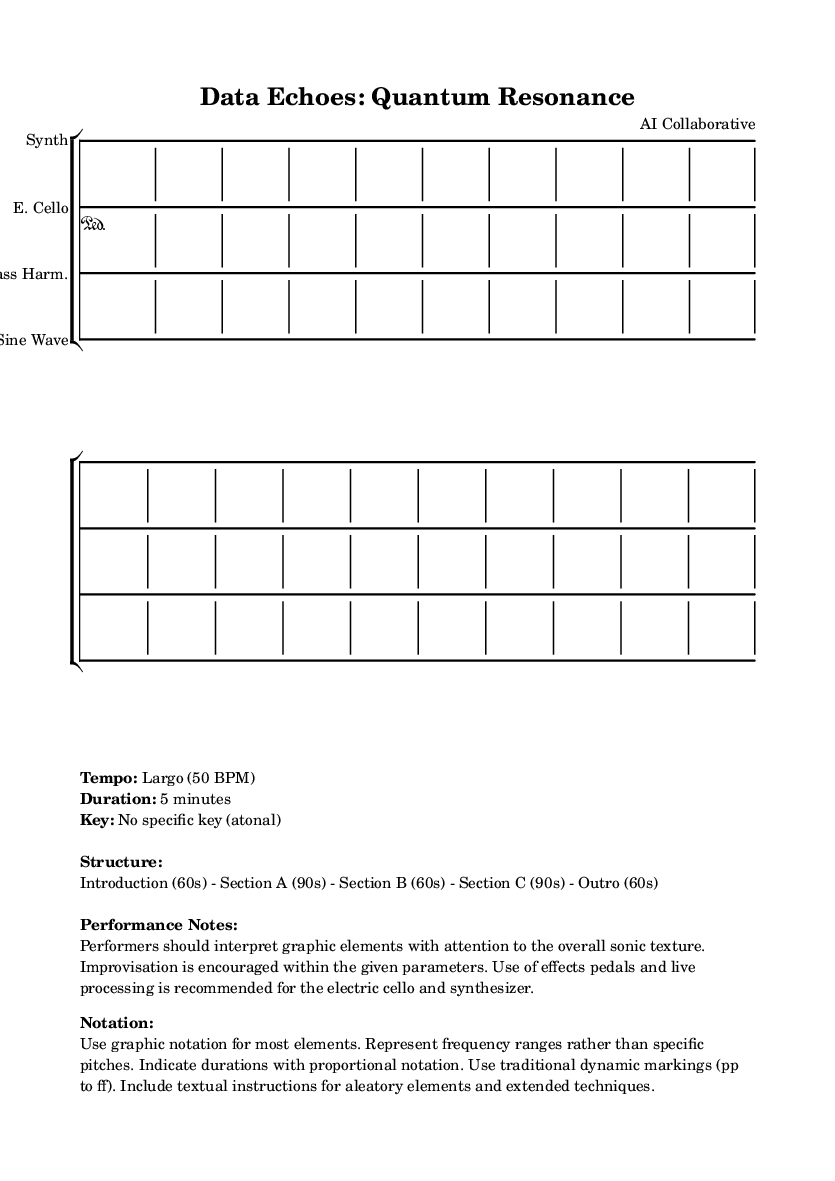What is the tempo of this music? The tempo indicated in the markup section states "Largo (50 BPM)." This is explicitly mentioned under the tempo section.
Answer: Largo (50 BPM) What is the duration of the piece? The duration of the piece is stated in the markup as "5 minutes." This is a direct piece of information provided in the score details.
Answer: 5 minutes What is the time signature? The time signature specified for the music is "4/4" as seen in each staff grouping. This indicates the number of beats in each measure.
Answer: 4/4 Which instruments are used in this composition? The instruments listed in the score are "Synth," "E. Cello," "Glass Harm.," and "Sine Wave." These are mentioned directly in the staff headers.
Answer: Synth, E. Cello, Glass Harm., Sine Wave What is the overall structure of the piece? The structure outlined in the markup describes the sections as follows: "Introduction (60s) - Section A (90s) - Section B (60s) - Section C (90s) - Outro (60s)." This gives a clear breakdown of the time allocations for each part.
Answer: Introduction, Section A, Section B, Section C, Outro What type of notation is primarily used in this score? The score specifies the use of "graphic notation" for most elements. This is highlighted in the notation section in the markup, indicating the creative nature of the piece.
Answer: Graphic notation What improvisational elements are allowed in the performance? The performance notes suggest that "Improvisation is encouraged within the given parameters." This indicates the freedom for performers to explore creativity while adhering to the score's structure.
Answer: Improvisation is encouraged 